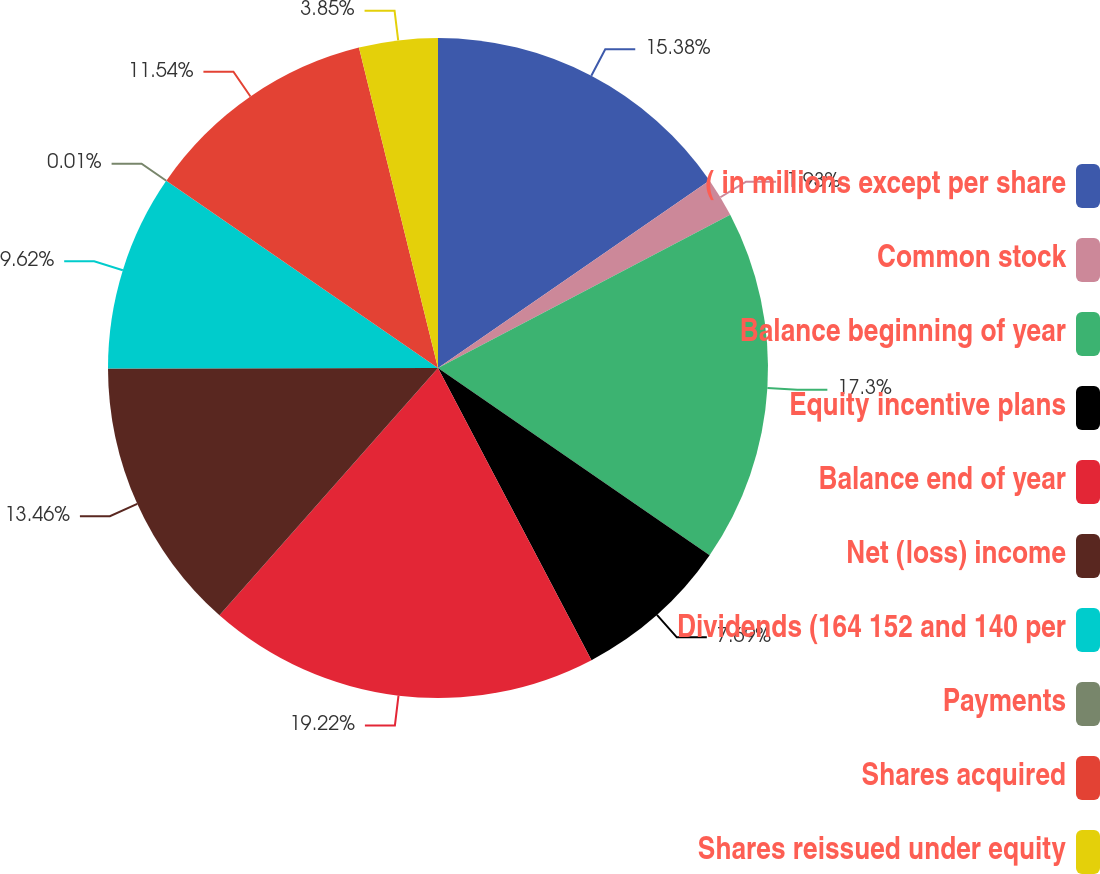<chart> <loc_0><loc_0><loc_500><loc_500><pie_chart><fcel>( in millions except per share<fcel>Common stock<fcel>Balance beginning of year<fcel>Equity incentive plans<fcel>Balance end of year<fcel>Net (loss) income<fcel>Dividends (164 152 and 140 per<fcel>Payments<fcel>Shares acquired<fcel>Shares reissued under equity<nl><fcel>15.38%<fcel>1.93%<fcel>17.3%<fcel>7.69%<fcel>19.22%<fcel>13.46%<fcel>9.62%<fcel>0.01%<fcel>11.54%<fcel>3.85%<nl></chart> 